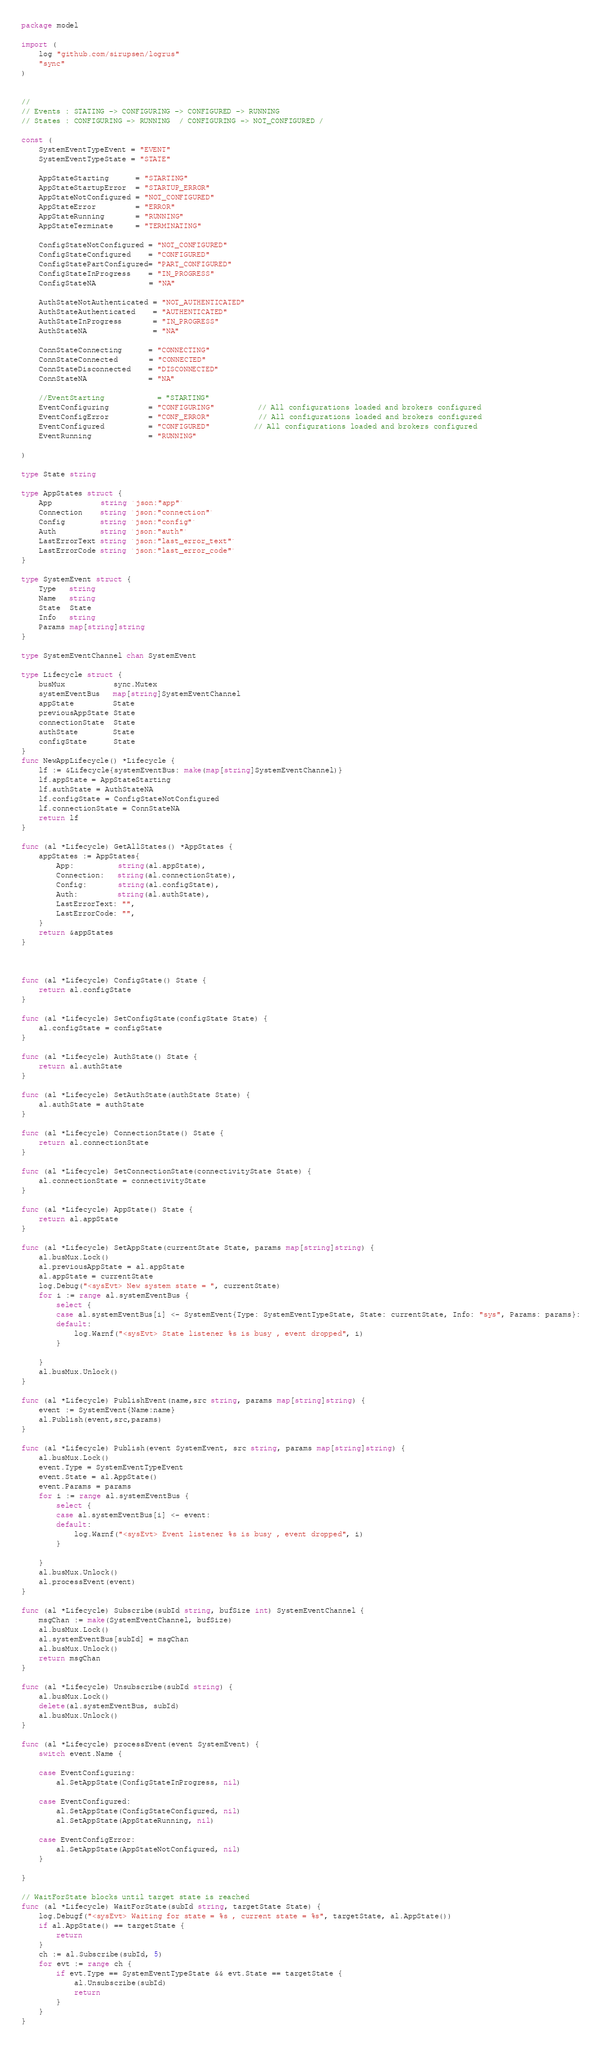<code> <loc_0><loc_0><loc_500><loc_500><_Go_>package model

import (
	log "github.com/sirupsen/logrus"
	"sync"
)


//
// Events : STATING -> CONFIGURING -> CONFIGURED -> RUNNING
// States : CONFIGURING -> RUNNING  / CONFIGURING -> NOT_CONFIGURED /

const (
	SystemEventTypeEvent = "EVENT"
	SystemEventTypeState = "STATE"

	AppStateStarting      = "STARTING"
	AppStateStartupError  = "STARTUP_ERROR"
	AppStateNotConfigured = "NOT_CONFIGURED"
	AppStateError         = "ERROR"
	AppStateRunning       = "RUNNING"
	AppStateTerminate     = "TERMINATING"

	ConfigStateNotConfigured = "NOT_CONFIGURED"
	ConfigStateConfigured    = "CONFIGURED"
	ConfigStatePartConfigured= "PART_CONFIGURED"
	ConfigStateInProgress    = "IN_PROGRESS"
	ConfigStateNA            = "NA"

	AuthStateNotAuthenticated = "NOT_AUTHENTICATED"
	AuthStateAuthenticated    = "AUTHENTICATED"
	AuthStateInProgress       = "IN_PROGRESS"
	AuthStateNA               = "NA"

	ConnStateConnecting      = "CONNECTING"
	ConnStateConnected       = "CONNECTED"
	ConnStateDisconnected    = "DISCONNECTED"
	ConnStateNA              = "NA"

	//EventStarting            = "STARTING"
	EventConfiguring         = "CONFIGURING"          // All configurations loaded and brokers configured
	EventConfigError         = "CONF_ERROR"           // All configurations loaded and brokers configured
	EventConfigured          = "CONFIGURED"          // All configurations loaded and brokers configured
	EventRunning             = "RUNNING"

)

type State string

type AppStates struct {
	App           string `json:"app"`
	Connection    string `json:"connection"`
	Config        string `json:"config"`
	Auth          string `json:"auth"`
	LastErrorText string `json:"last_error_text"`
	LastErrorCode string `json:"last_error_code"`
}

type SystemEvent struct {
	Type   string
	Name   string
	State  State
	Info   string
	Params map[string]string
}

type SystemEventChannel chan SystemEvent

type Lifecycle struct {
	busMux           sync.Mutex
	systemEventBus   map[string]SystemEventChannel
	appState         State
	previousAppState State
	connectionState  State
	authState        State
	configState      State
}
func NewAppLifecycle() *Lifecycle {
	lf := &Lifecycle{systemEventBus: make(map[string]SystemEventChannel)}
	lf.appState = AppStateStarting
	lf.authState = AuthStateNA
	lf.configState = ConfigStateNotConfigured
	lf.connectionState = ConnStateNA
	return lf
}

func (al *Lifecycle) GetAllStates() *AppStates {
	appStates := AppStates{
		App:          string(al.appState),
		Connection:   string(al.connectionState),
		Config:       string(al.configState),
		Auth:         string(al.authState),
		LastErrorText: "",
		LastErrorCode: "",
	}
	return &appStates
}



func (al *Lifecycle) ConfigState() State {
	return al.configState
}

func (al *Lifecycle) SetConfigState(configState State) {
	al.configState = configState
}

func (al *Lifecycle) AuthState() State {
	return al.authState
}

func (al *Lifecycle) SetAuthState(authState State) {
	al.authState = authState
}

func (al *Lifecycle) ConnectionState() State {
	return al.connectionState
}

func (al *Lifecycle) SetConnectionState(connectivityState State) {
	al.connectionState = connectivityState
}

func (al *Lifecycle) AppState() State {
	return al.appState
}

func (al *Lifecycle) SetAppState(currentState State, params map[string]string) {
	al.busMux.Lock()
	al.previousAppState = al.appState
	al.appState = currentState
	log.Debug("<sysEvt> New system state = ", currentState)
	for i := range al.systemEventBus {
		select {
		case al.systemEventBus[i] <- SystemEvent{Type: SystemEventTypeState, State: currentState, Info: "sys", Params: params}:
		default:
			log.Warnf("<sysEvt> State listener %s is busy , event dropped", i)
		}

	}
	al.busMux.Unlock()
}

func (al *Lifecycle) PublishEvent(name,src string, params map[string]string) {
	event := SystemEvent{Name:name}
	al.Publish(event,src,params)
}

func (al *Lifecycle) Publish(event SystemEvent, src string, params map[string]string) {
	al.busMux.Lock()
	event.Type = SystemEventTypeEvent
	event.State = al.AppState()
	event.Params = params
	for i := range al.systemEventBus {
		select {
		case al.systemEventBus[i] <- event:
		default:
			log.Warnf("<sysEvt> Event listener %s is busy , event dropped", i)
		}

	}
	al.busMux.Unlock()
	al.processEvent(event)
}

func (al *Lifecycle) Subscribe(subId string, bufSize int) SystemEventChannel {
	msgChan := make(SystemEventChannel, bufSize)
	al.busMux.Lock()
	al.systemEventBus[subId] = msgChan
	al.busMux.Unlock()
	return msgChan
}

func (al *Lifecycle) Unsubscribe(subId string) {
	al.busMux.Lock()
	delete(al.systemEventBus, subId)
	al.busMux.Unlock()
}

func (al *Lifecycle) processEvent(event SystemEvent) {
	switch event.Name {

	case EventConfiguring:
		al.SetAppState(ConfigStateInProgress, nil)

	case EventConfigured:
		al.SetAppState(ConfigStateConfigured, nil)
		al.SetAppState(AppStateRunning, nil)

	case EventConfigError:
		al.SetAppState(AppStateNotConfigured, nil)
	}

}

// WaitForState blocks until target state is reached
func (al *Lifecycle) WaitForState(subId string, targetState State) {
	log.Debugf("<sysEvt> Waiting for state = %s , current state = %s", targetState, al.AppState())
	if al.AppState() == targetState {
		return
	}
	ch := al.Subscribe(subId, 5)
	for evt := range ch {
		if evt.Type == SystemEventTypeState && evt.State == targetState {
			al.Unsubscribe(subId)
			return
		}
	}
}
</code> 